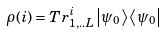<formula> <loc_0><loc_0><loc_500><loc_500>\rho ( i ) = T r _ { 1 , . . L } ^ { i } \left | \psi _ { 0 } \right \rangle \left \langle \psi _ { 0 } \right |</formula> 